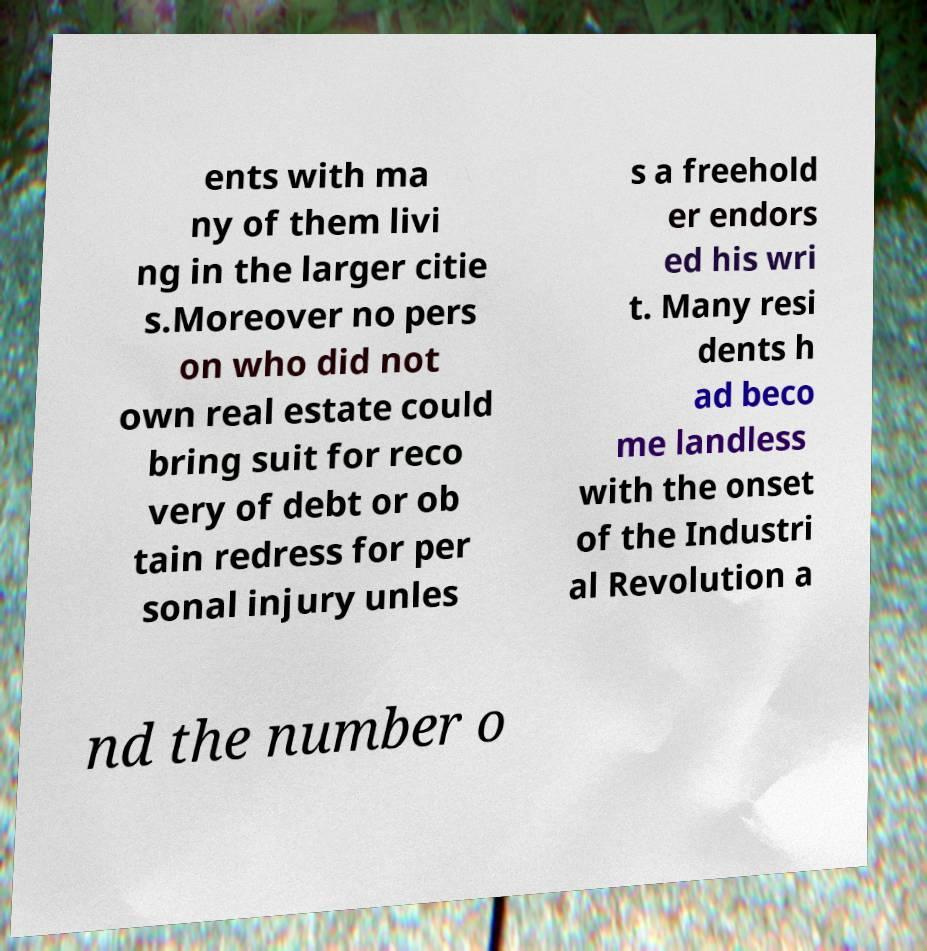Could you assist in decoding the text presented in this image and type it out clearly? ents with ma ny of them livi ng in the larger citie s.Moreover no pers on who did not own real estate could bring suit for reco very of debt or ob tain redress for per sonal injury unles s a freehold er endors ed his wri t. Many resi dents h ad beco me landless with the onset of the Industri al Revolution a nd the number o 